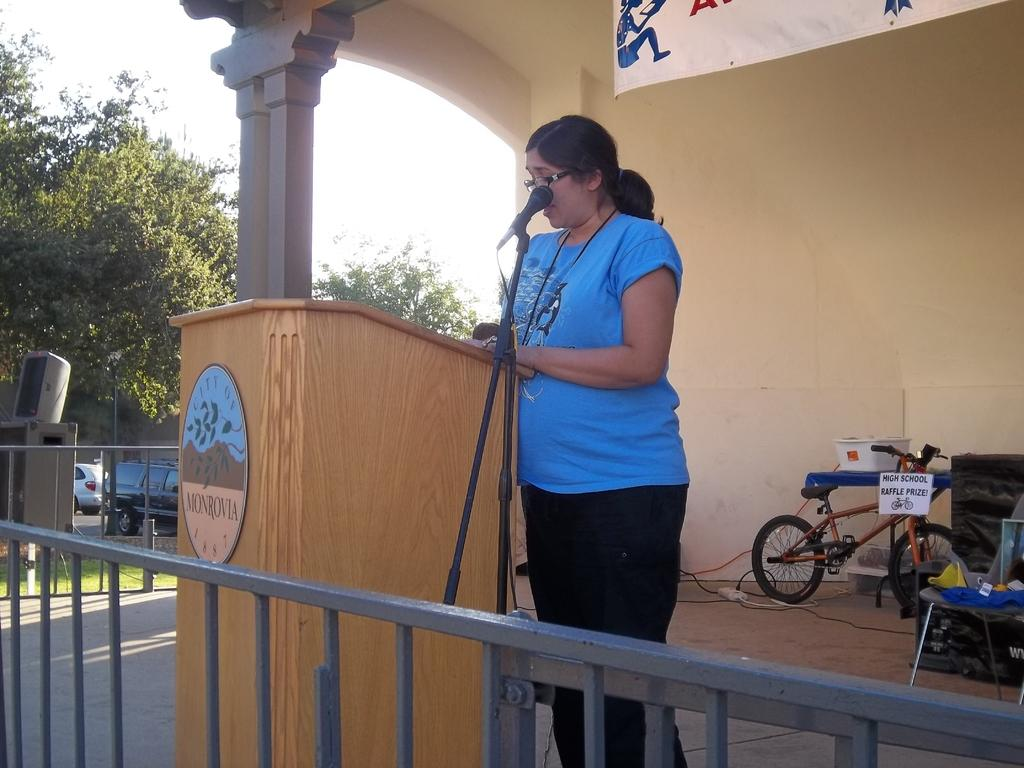What type of natural elements can be seen in the image? There are trees in the image. What part of the natural environment is visible in the image? The sky is visible in the image. What type of vehicles are present in the image? There are cars in the image. What additional object can be seen in the image? There is a banner in the image. What type of transportation is present for children in the image? There is a small bicycle in the image. Who is present in the image? There is a woman in the image. What is the woman wearing in the image? The woman is wearing a blue t-shirt. What object is in front of the woman in the image? There is a mic in front of the woman. What scent can be detected coming from the box in the image? There is no box present in the image, so it is not possible to determine any scent. 